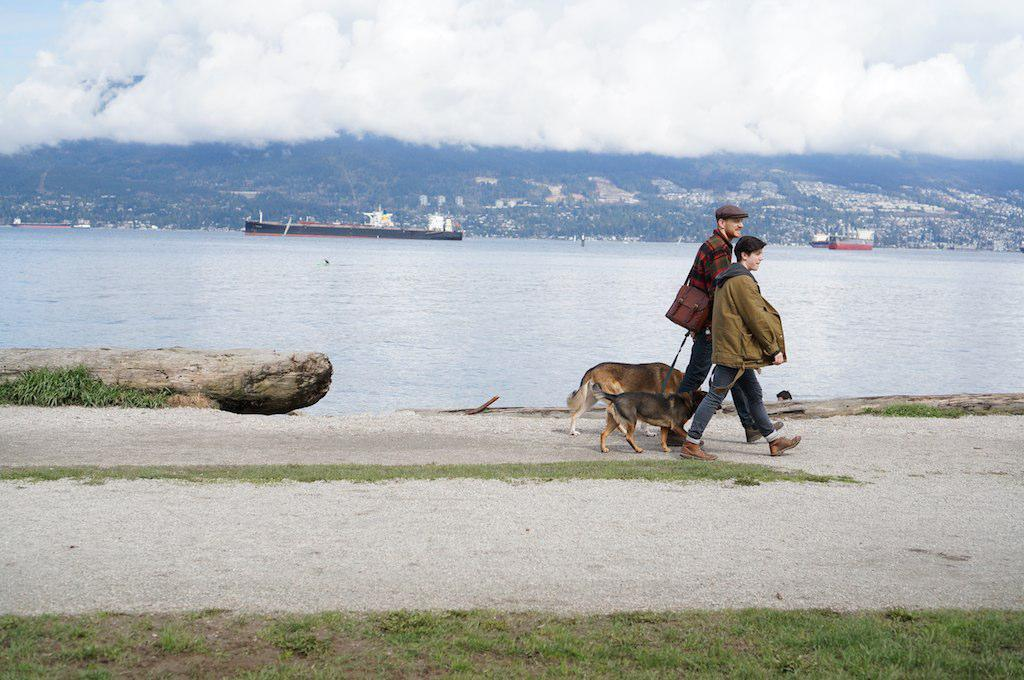How many people are in the image? There are two persons in the image. What are the persons doing in the image? The persons are walking. What are the persons holding in the image? The persons are holding a belt that is tightened to dogs. What natural features can be seen in the image? There is a mountain and a river in the image. What man-made objects can be seen in the image? There are ships in the image. How would you describe the weather in the image? The sky is cloudy in the image. Where is the jail located in the image? There is no jail present in the image. What color is the heart on the mountain in the image? There is no heart on the mountain in the image. 